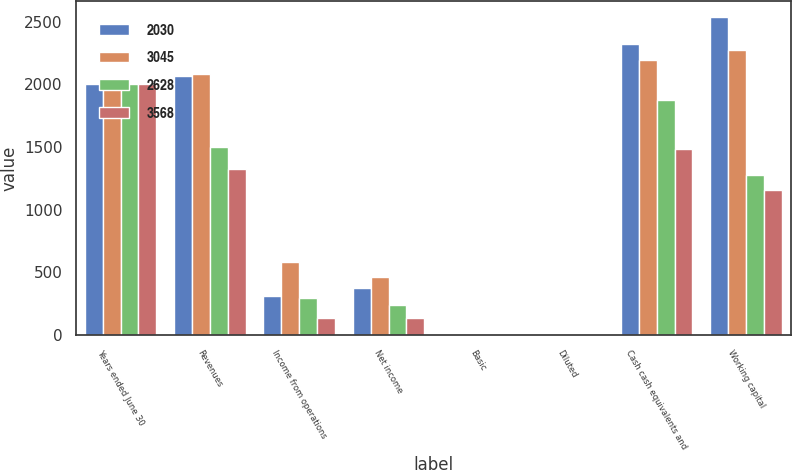Convert chart. <chart><loc_0><loc_0><loc_500><loc_500><stacked_bar_chart><ecel><fcel>Years ended June 30<fcel>Revenues<fcel>Income from operations<fcel>Net income<fcel>Basic<fcel>Diluted<fcel>Cash cash equivalents and<fcel>Working capital<nl><fcel>2030<fcel>2006<fcel>2071<fcel>310<fcel>380<fcel>1.92<fcel>1.86<fcel>2326<fcel>2541<nl><fcel>3045<fcel>2005<fcel>2085<fcel>583<fcel>467<fcel>2.38<fcel>2.32<fcel>2195<fcel>2271<nl><fcel>2628<fcel>2004<fcel>1497<fcel>297<fcel>244<fcel>1.25<fcel>1.21<fcel>1876<fcel>1280<nl><fcel>3568<fcel>2003<fcel>1323<fcel>139<fcel>137<fcel>0.72<fcel>0.7<fcel>1488<fcel>1155<nl></chart> 